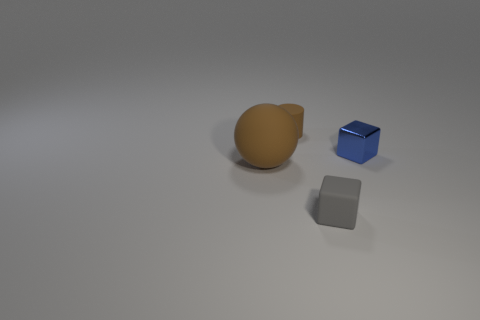Subtract all red cubes. Subtract all cyan cylinders. How many cubes are left? 2 Add 4 tiny brown rubber cylinders. How many objects exist? 8 Subtract all cylinders. How many objects are left? 3 Subtract 0 cyan cubes. How many objects are left? 4 Subtract all large red matte spheres. Subtract all brown spheres. How many objects are left? 3 Add 4 tiny brown rubber objects. How many tiny brown rubber objects are left? 5 Add 2 matte cylinders. How many matte cylinders exist? 3 